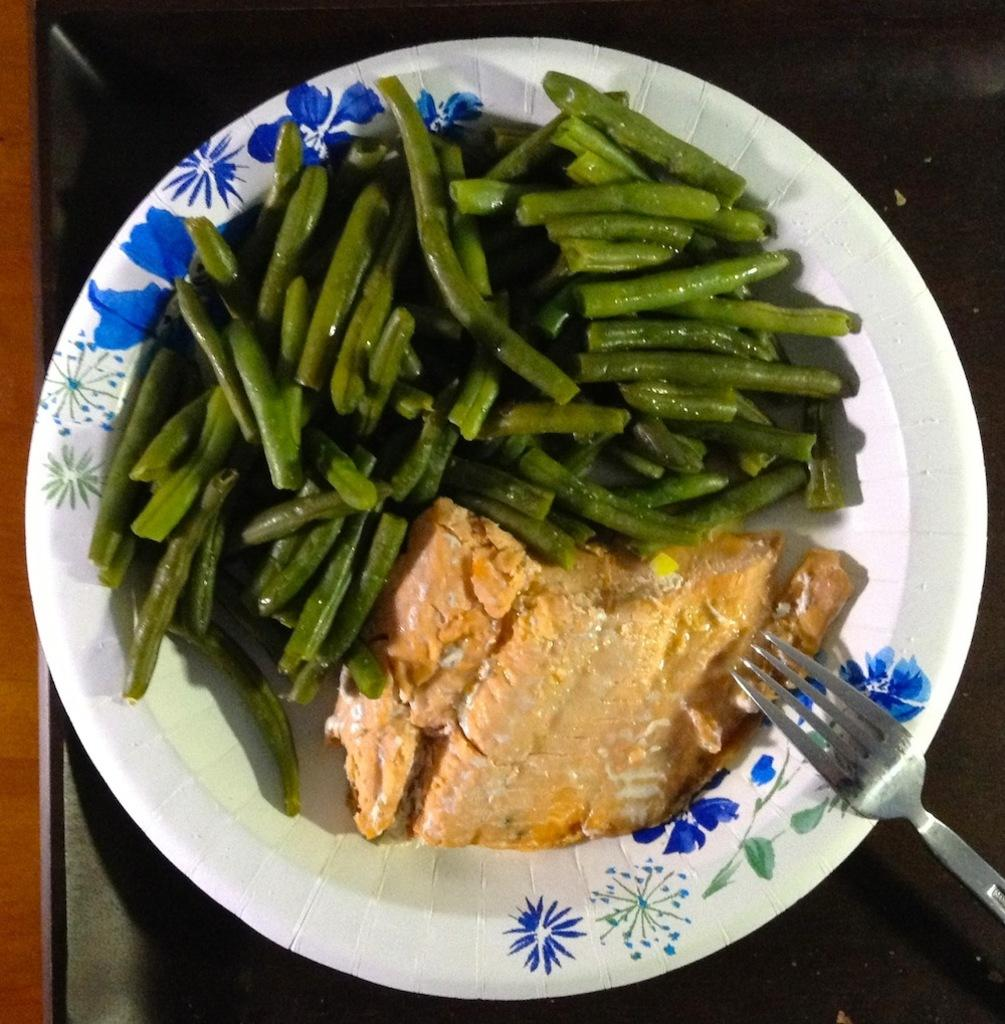What type of food items can be seen in the image? There are vegetables and bread in the image. What utensil is present in the image? There is a fork in the image. What is the plate placed on in the image? The plate is placed on a table in the image. What trade agreement is being discussed in the image? There is no discussion or trade agreement present in the image; it features vegetables, bread, a fork, and a plate on a table. What channel is the father watching in the image? There is no father or television present in the image. 